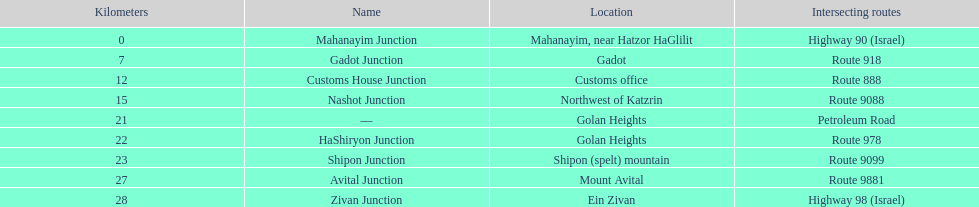What is the total kilometers that separates the mahanayim junction and the shipon junction? 23. 